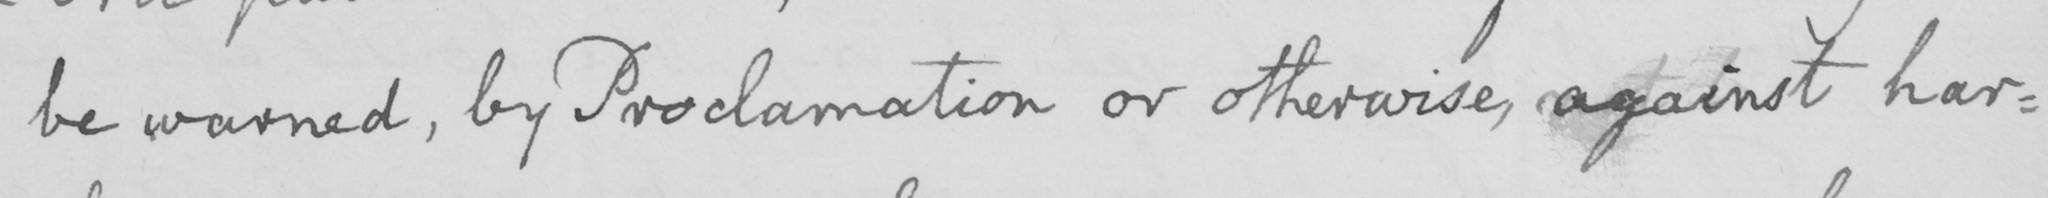What does this handwritten line say? be warned , by Proclamation or otherwise , against har : 